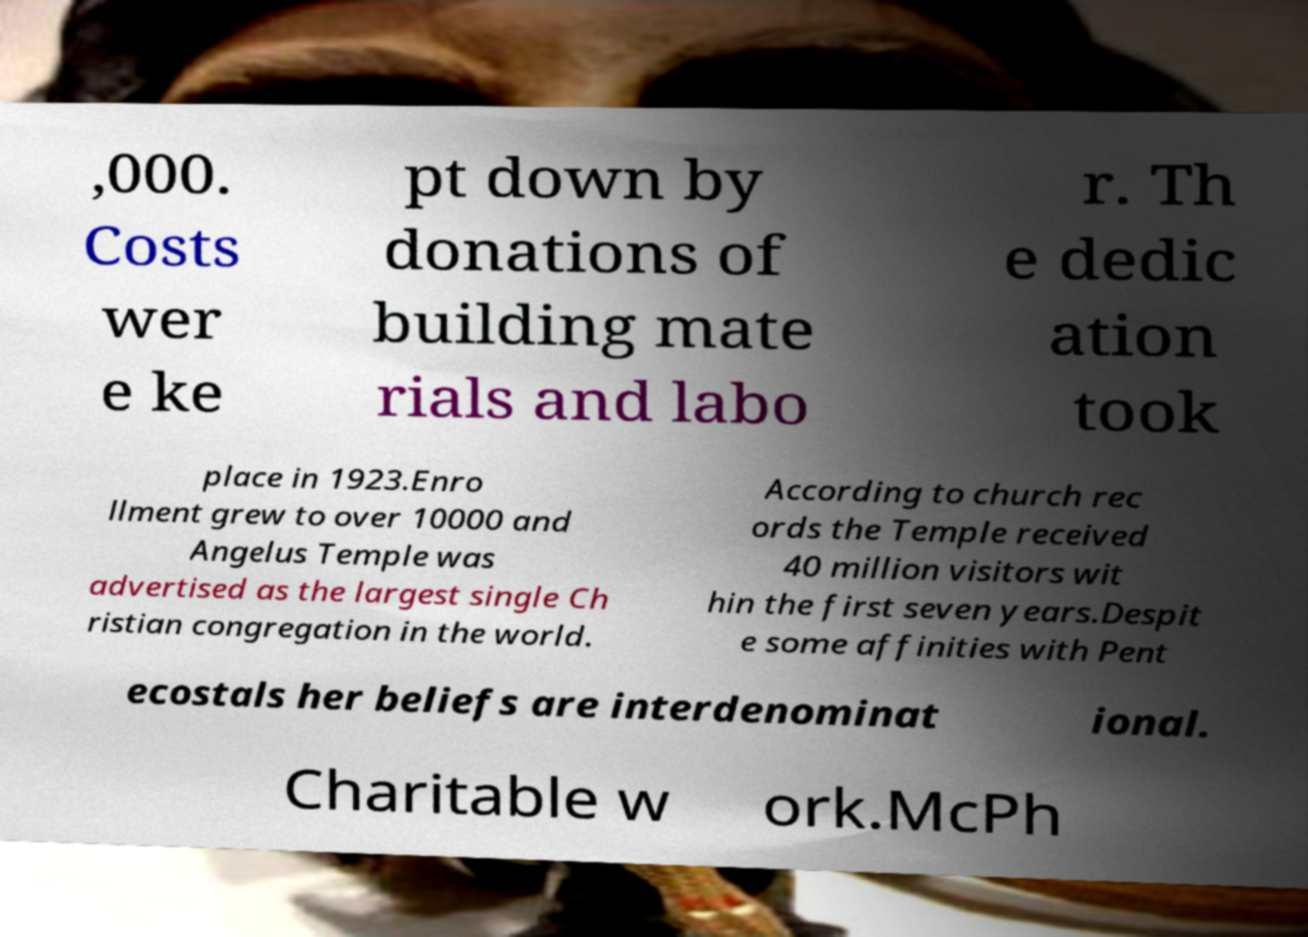Can you accurately transcribe the text from the provided image for me? ,000. Costs wer e ke pt down by donations of building mate rials and labo r. Th e dedic ation took place in 1923.Enro llment grew to over 10000 and Angelus Temple was advertised as the largest single Ch ristian congregation in the world. According to church rec ords the Temple received 40 million visitors wit hin the first seven years.Despit e some affinities with Pent ecostals her beliefs are interdenominat ional. Charitable w ork.McPh 